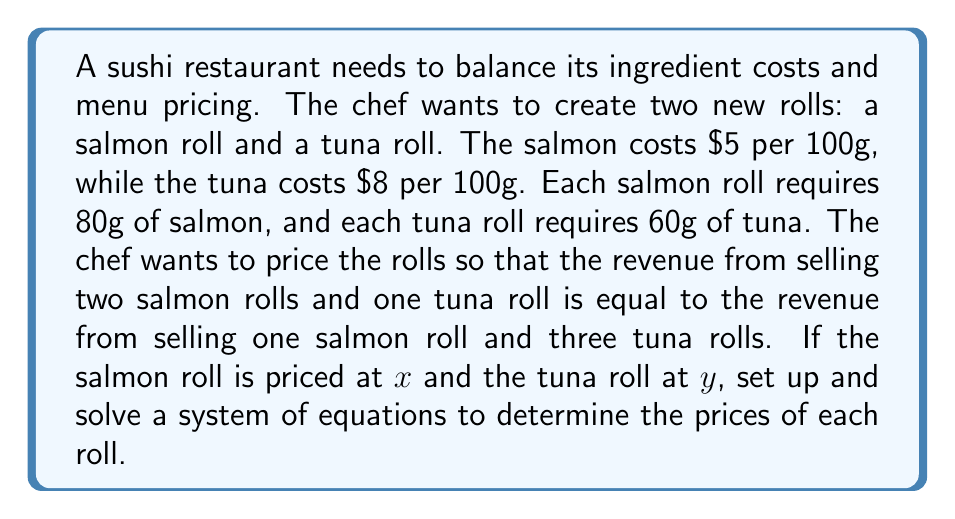Could you help me with this problem? Let's approach this step-by-step:

1) First, let's set up the equation for the revenue equality:
   $$2x + y = x + 3y$$

2) Now, we need another equation. We can use the cost information to create a relationship between $x$ and $y$. Let's assume the chef wants a 50% profit margin on each roll.

   For the salmon roll:
   Cost = $5 * (80/100) = $4
   Price = Cost * 1.5 = $6
   So, $x = 6$

   For the tuna roll:
   Cost = $8 * (60/100) = $4.80
   Price = Cost * 1.5 = $7.20
   So, $y = 7.20$

3) Now we have a system of two equations:
   $$2x + y = x + 3y$$
   $$x = 6$$

4) Substitute $x = 6$ into the first equation:
   $$2(6) + y = 6 + 3y$$
   $$12 + y = 6 + 3y$$

5) Solve for $y$:
   $$12 - 6 = 3y - y$$
   $$6 = 2y$$
   $$y = 3$$

6) However, this conflicts with our initial assumption that $y = 7.20$. This means the chef cannot achieve the desired revenue equality with a 50% profit margin on both rolls.

7) Let's solve the original equation with $x = 6$:
   $$2(6) + y = 6 + 3y$$
   $$12 + y = 6 + 3y$$
   $$6 = 2y$$
   $$y = 3$$

Therefore, to achieve the desired revenue equality, the salmon roll should be priced at $6 and the tuna roll at $3.
Answer: Salmon roll: $6, Tuna roll: $3 